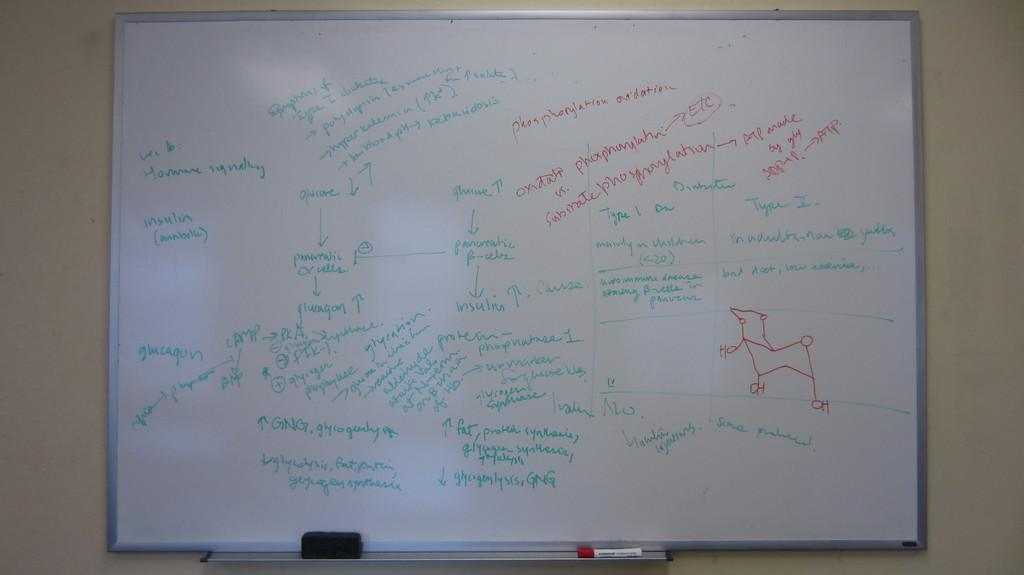<image>
Relay a brief, clear account of the picture shown. A white board with chemistry related drawing and writing such as insulin, glucagon, etc.. 